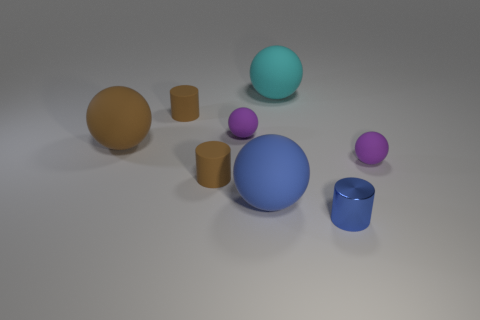Subtract all brown cylinders. How many were subtracted if there are1brown cylinders left? 1 Subtract 0 purple cylinders. How many objects are left? 8 Subtract all spheres. How many objects are left? 3 Subtract 1 cylinders. How many cylinders are left? 2 Subtract all yellow balls. Subtract all purple blocks. How many balls are left? 5 Subtract all gray cylinders. How many yellow balls are left? 0 Subtract all big rubber cylinders. Subtract all matte things. How many objects are left? 1 Add 6 small brown objects. How many small brown objects are left? 8 Add 8 cyan things. How many cyan things exist? 9 Add 1 large green blocks. How many objects exist? 9 